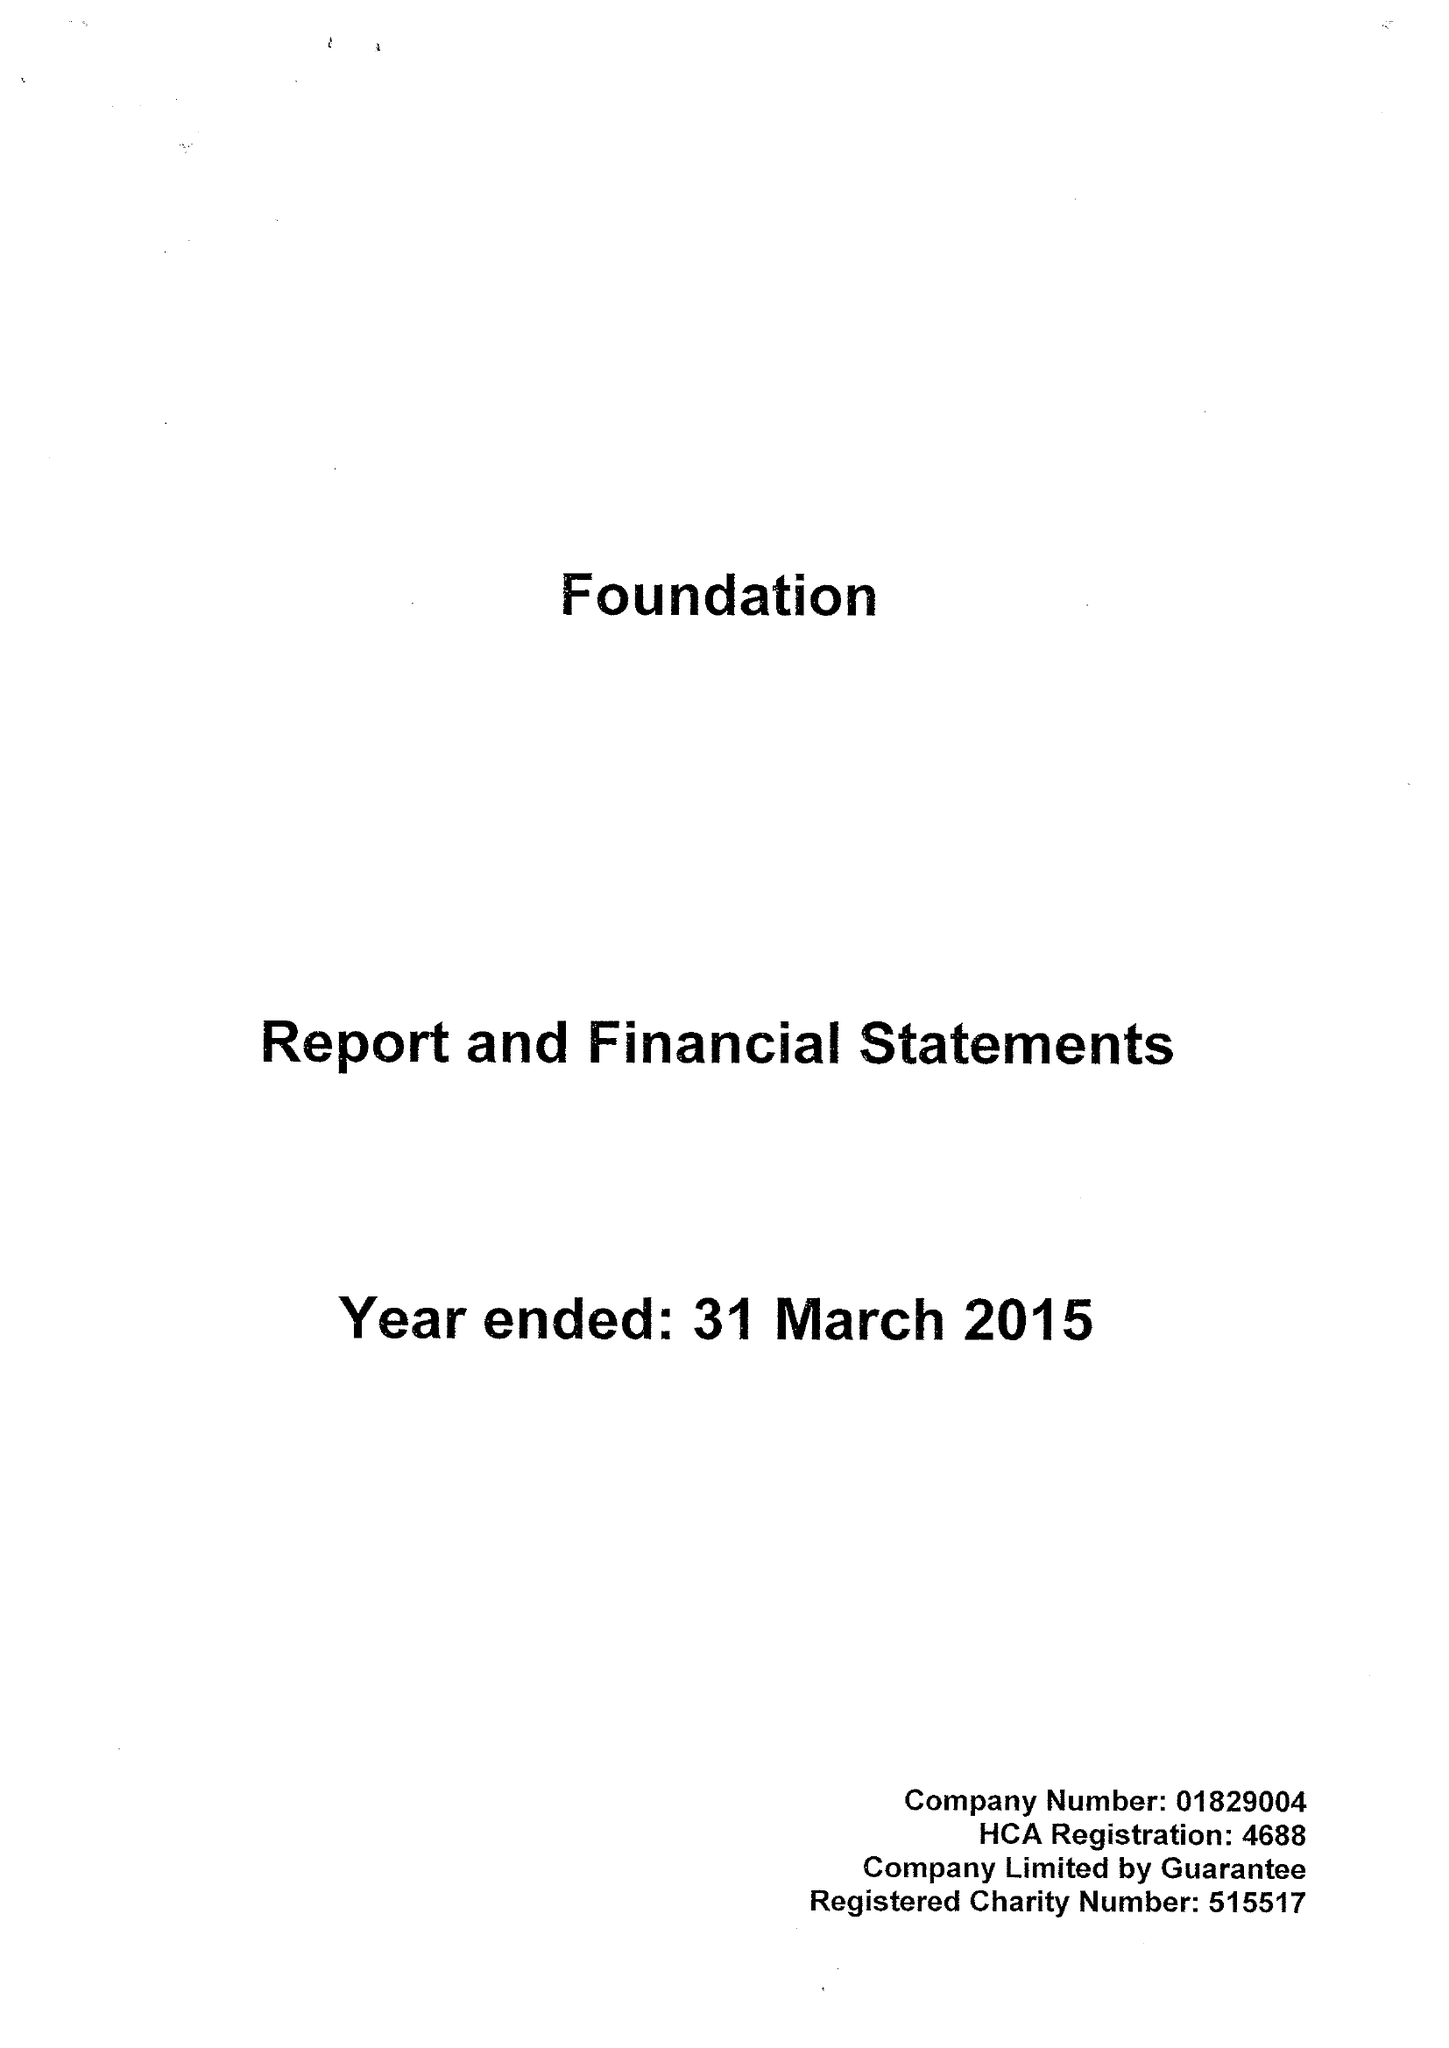What is the value for the charity_name?
Answer the question using a single word or phrase. Foundation 